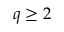<formula> <loc_0><loc_0><loc_500><loc_500>q \geq 2</formula> 